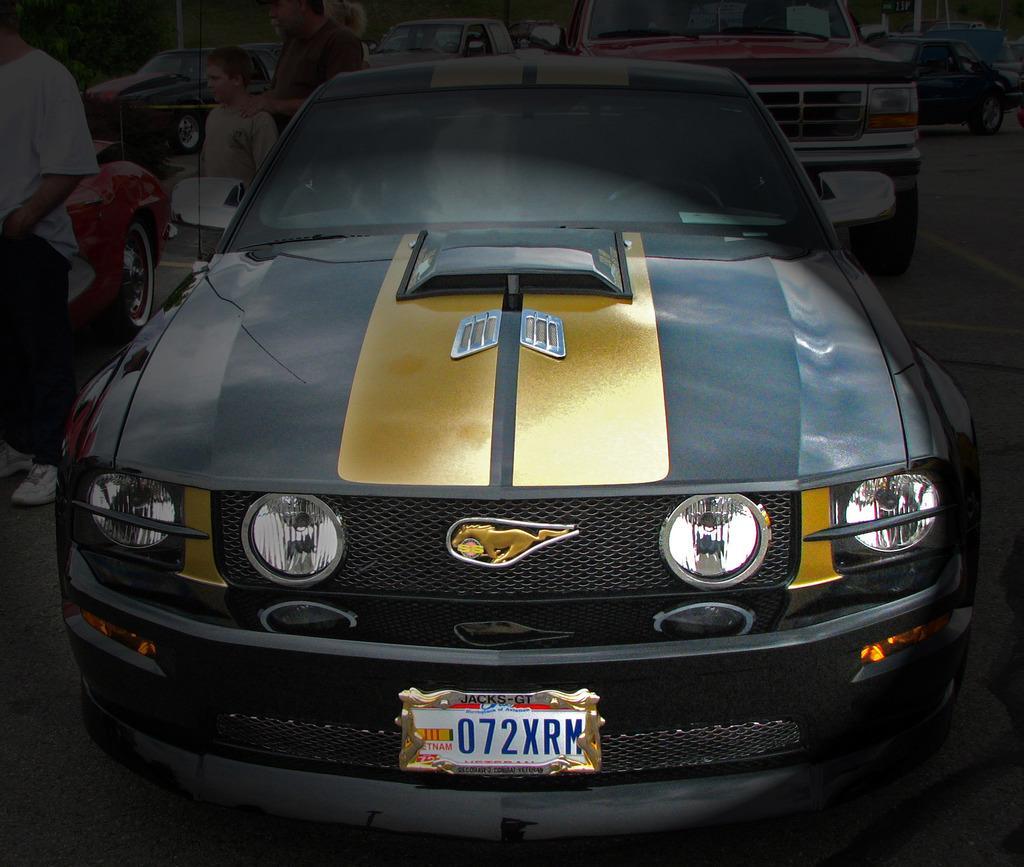Can you describe this image briefly? In this image we can see few vehicles and people standing on the road. 